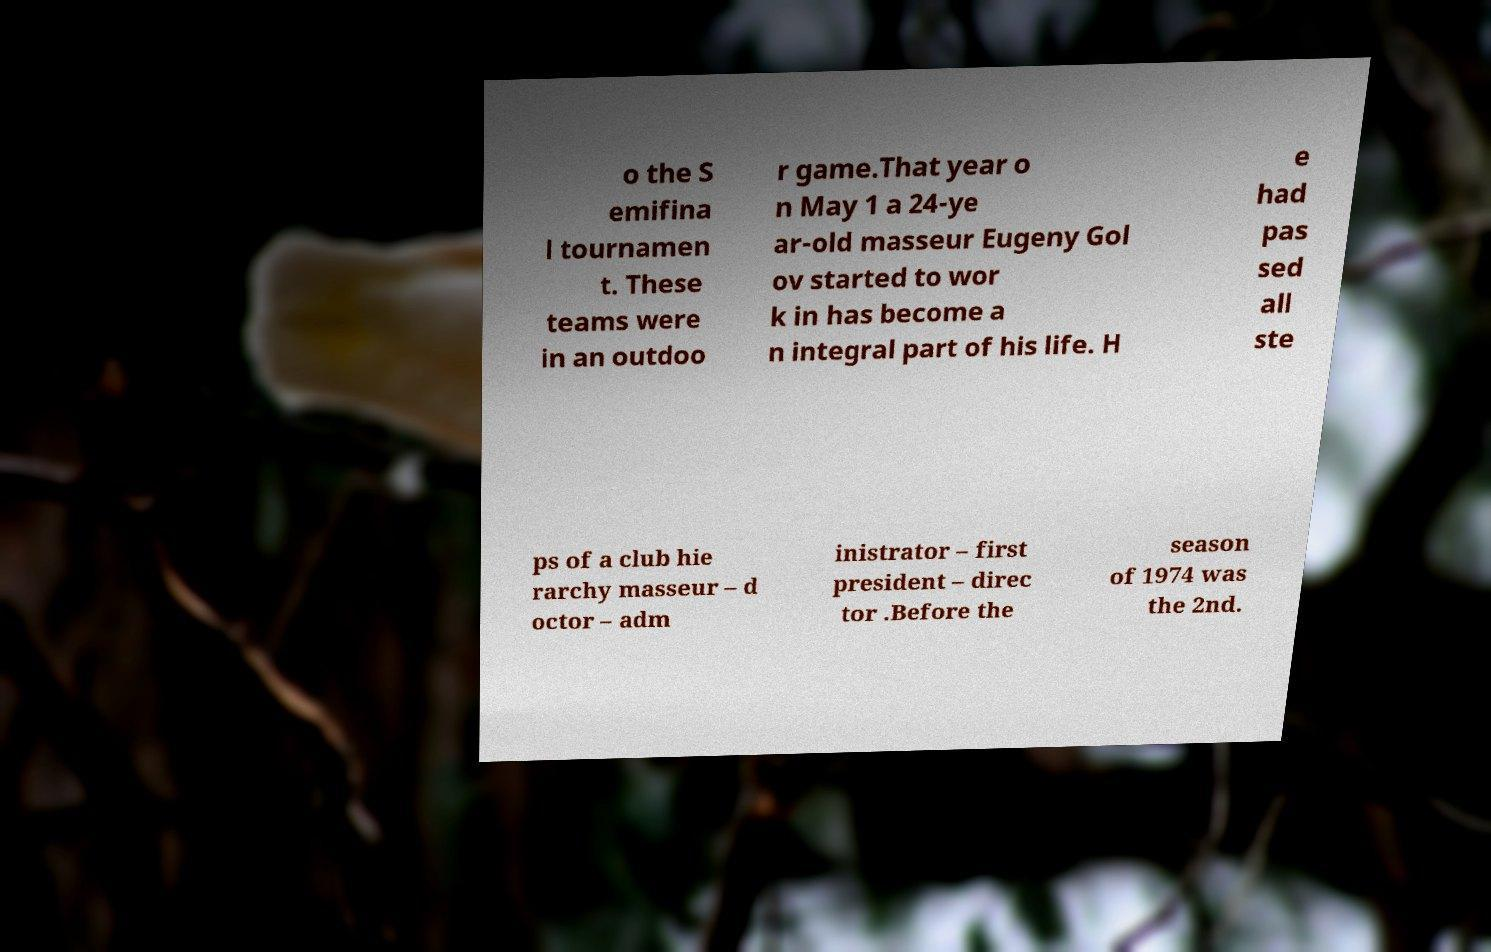For documentation purposes, I need the text within this image transcribed. Could you provide that? o the S emifina l tournamen t. These teams were in an outdoo r game.That year o n May 1 a 24-ye ar-old masseur Eugeny Gol ov started to wor k in has become a n integral part of his life. H e had pas sed all ste ps of a club hie rarchy masseur – d octor – adm inistrator – first president – direc tor .Before the season of 1974 was the 2nd. 